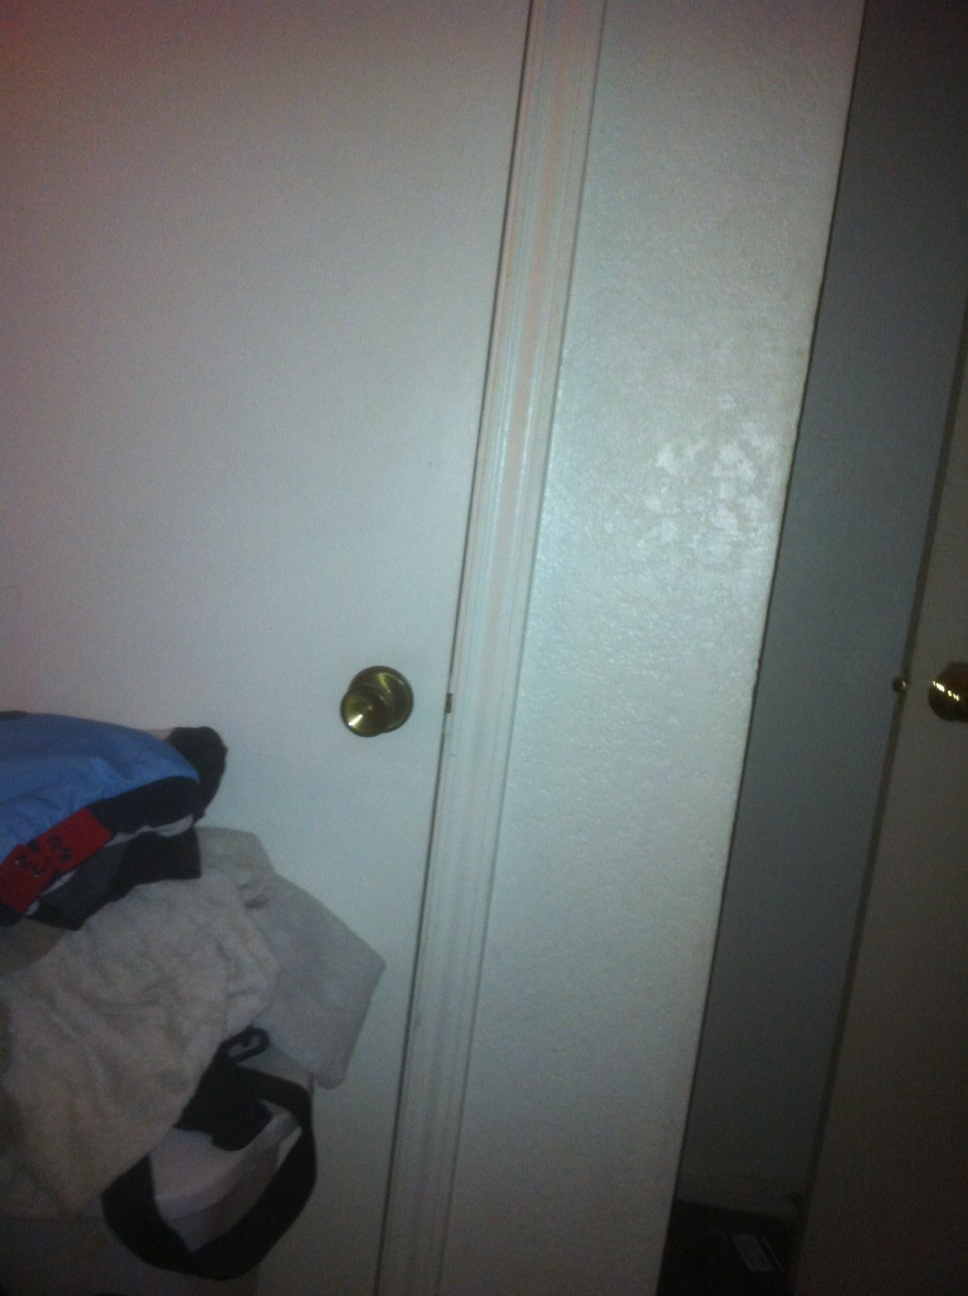What types of items can you see on the floor near the door in this image? On the floor near the door, there are several items including a stack of clothes which appear to be sweatshirts or t-shirts and a black bag, possibly used for carrying accessories or gym gear. 